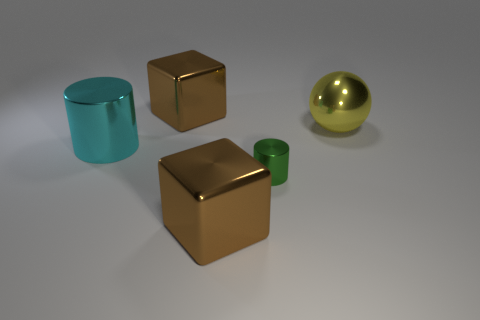Add 4 large yellow metal objects. How many objects exist? 9 Subtract all cylinders. How many objects are left? 3 Add 5 metal balls. How many metal balls are left? 6 Add 3 red rubber spheres. How many red rubber spheres exist? 3 Subtract 0 brown cylinders. How many objects are left? 5 Subtract all brown objects. Subtract all big cylinders. How many objects are left? 2 